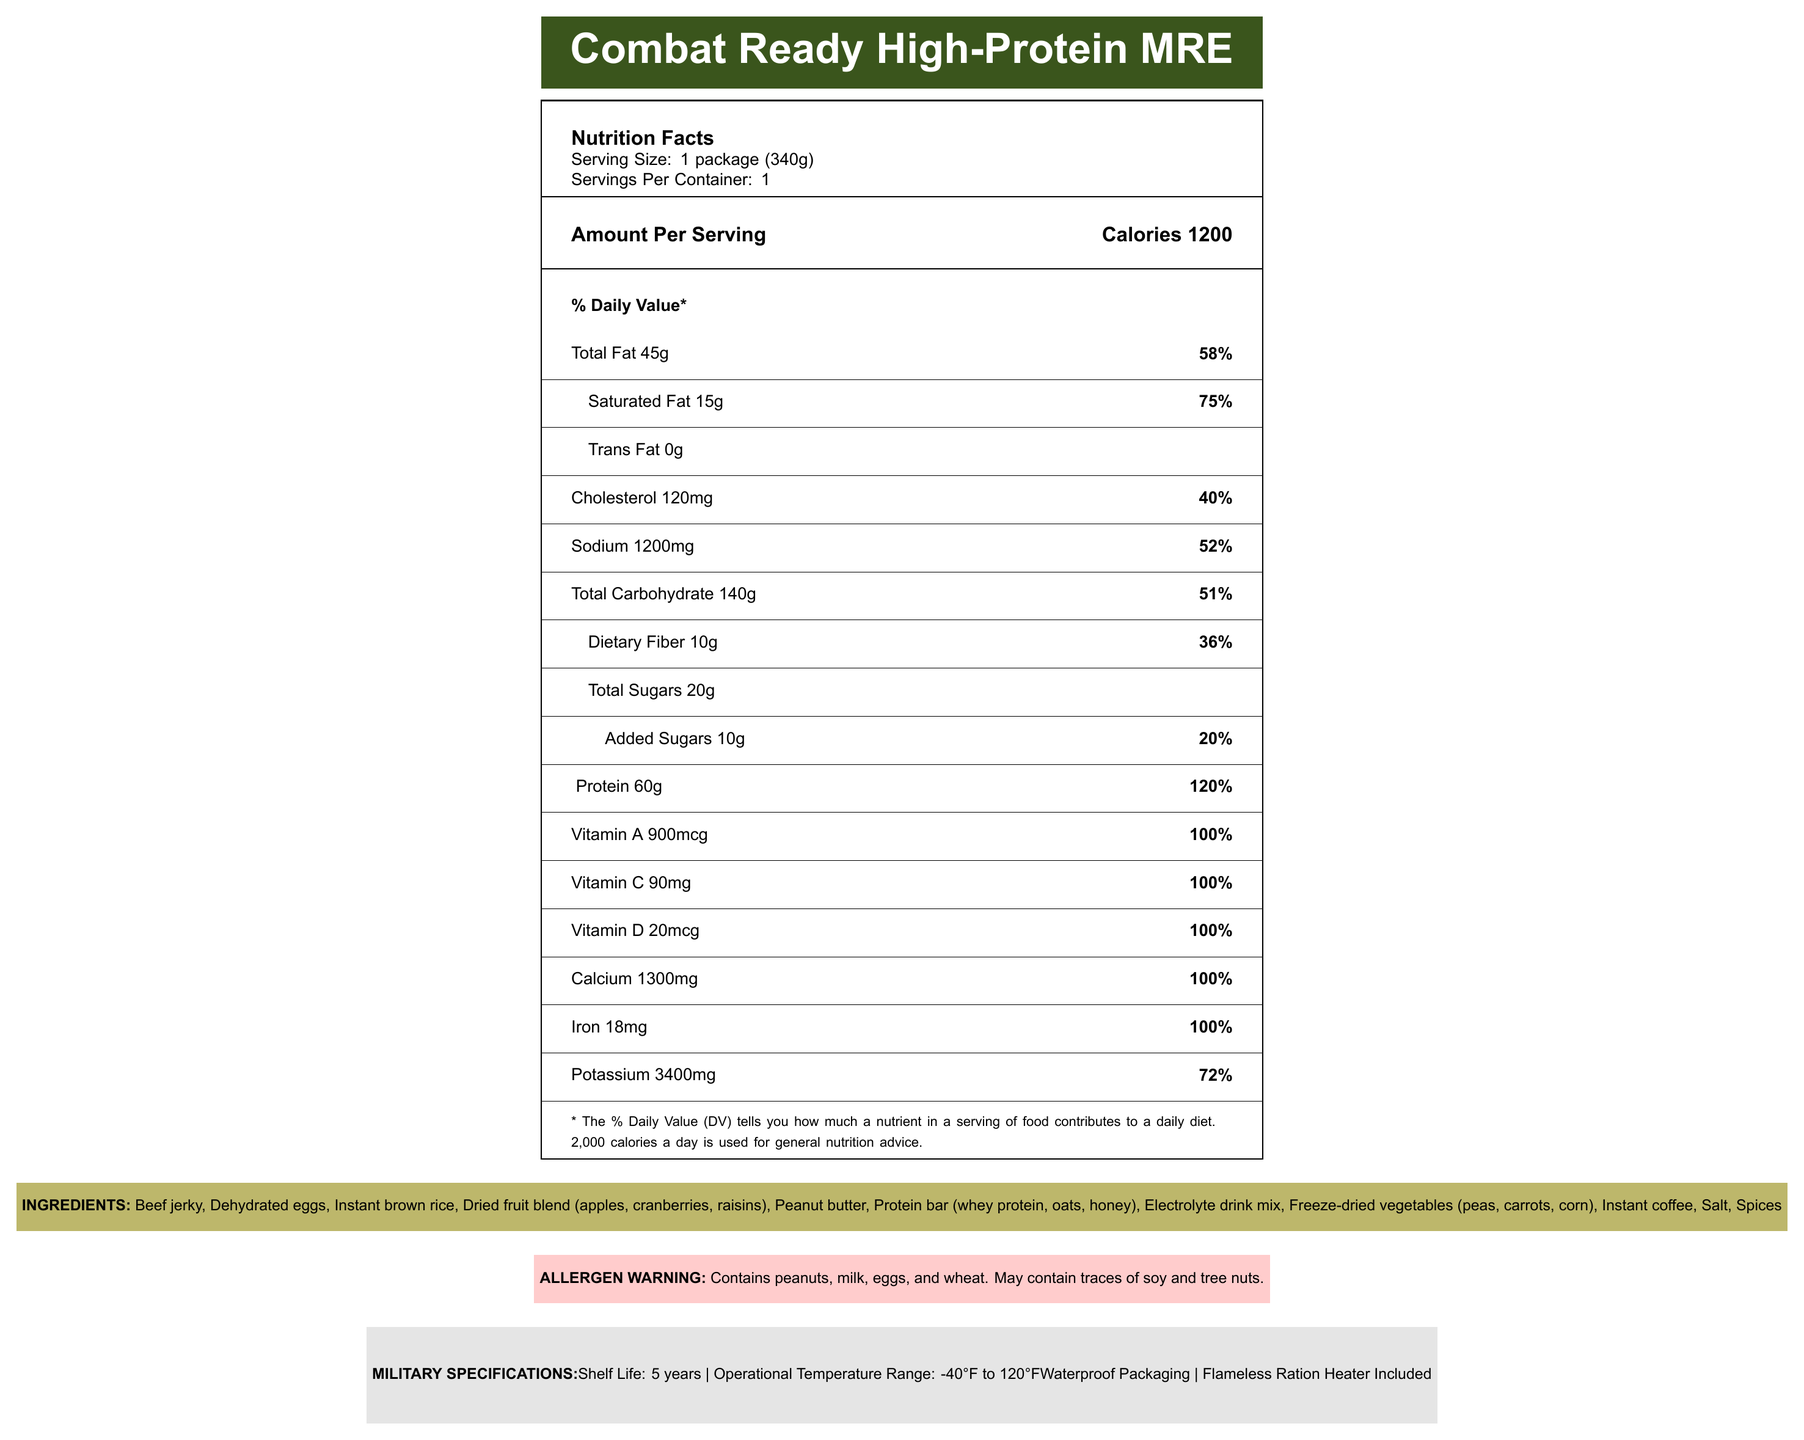What is the serving size of the Combat Ready High-Protein MRE? The document specifies the serving size as "1 package (340g)."
Answer: 1 package (340g) How many calories are in one serving of this MRE? The calories per serving are explicitly listed as 1200 calories.
Answer: 1200 calories What percentage of the daily value does the protein content represent? The document indicates that the protein content is 60g, which equals 120% of the daily value.
Answer: 120% What are the main ingredients in this MRE? The ingredients are listed under the "INGREDIENTS" section.
Answer: Beef jerky, Dehydrated eggs, Instant brown rice, Dried fruit blend (apples, cranberries, raisins), Peanut butter, Protein bar (whey protein, oats, honey), Electrolyte drink mix, Freeze-dried vegetables (peas, carrots, corn), Instant coffee, Salt, Spices Is this MRE safe for someone with a peanut allergy? The allergen warning clearly states that the MRE contains peanuts.
Answer: No What is the shelf life of this MRE? A. 3 years B. 4 years C. 5 years D. 6 years The document states the shelf life is 5 years in the "MILITARY SPECIFICATIONS" section.
Answer: C Which vitamin is not included in this MRE? A. Vitamin A B. Vitamin B12 C. Vitamin C D. Vitamin D The document lists Vitamin A, Vitamin C, and Vitamin D, but not Vitamin B12.
Answer: B Can this MRE be used in extreme temperatures? The document specifies that the operational temperature range is from -40°F to 120°F.
Answer: Yes Summarize the main nutritional aspects of this MRE. The document provides extensive nutrition information, military specifications, ingredients list, and allergen warnings. It emphasizes the high-protein content, various vitamins, and operational durability.
Answer: This high-protein MRE offers a comprehensive nutrient profile designed to support extended field operations. It includes 1200 calories per serving with substantial amounts of protein (60g), fats (45g), and carbohydrates (140g). The MRE also provides essential vitamins and minerals, meeting or exceeding 100% of the daily recommended values for several nutrients. Additionally, it features waterproof packaging and a flameless ration heater. Is the packaging waterproof? The "MILITARY SPECIFICATIONS" section confirms that the packaging is waterproof.
Answer: Yes How much potassium does one serving of this MRE contain? The document indicates that the potassium content is 3400mg per serving, accounting for 72% of the daily value.
Answer: 3400mg Can it be determined how the MRE is flavored based on the document? The flavor specifics are not provided in the document, making it impossible to determine the flavor from the information given.
Answer: No 